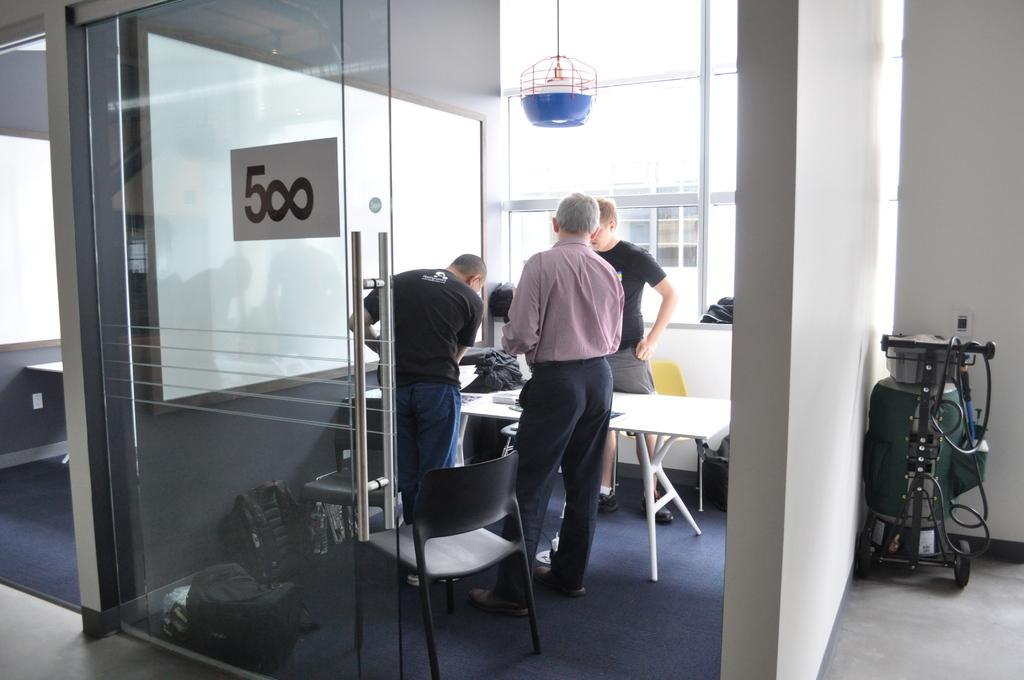<image>
Share a concise interpretation of the image provided. Employees discussing in meeting room 500 in their office. 